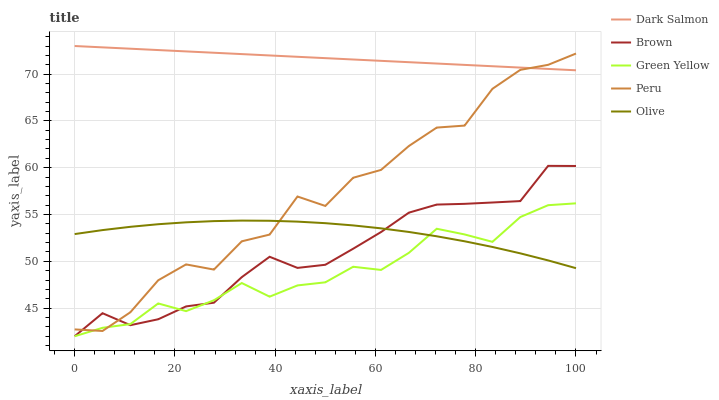Does Green Yellow have the minimum area under the curve?
Answer yes or no. Yes. Does Dark Salmon have the maximum area under the curve?
Answer yes or no. Yes. Does Brown have the minimum area under the curve?
Answer yes or no. No. Does Brown have the maximum area under the curve?
Answer yes or no. No. Is Dark Salmon the smoothest?
Answer yes or no. Yes. Is Peru the roughest?
Answer yes or no. Yes. Is Brown the smoothest?
Answer yes or no. No. Is Brown the roughest?
Answer yes or no. No. Does Brown have the lowest value?
Answer yes or no. Yes. Does Dark Salmon have the lowest value?
Answer yes or no. No. Does Dark Salmon have the highest value?
Answer yes or no. Yes. Does Brown have the highest value?
Answer yes or no. No. Is Green Yellow less than Dark Salmon?
Answer yes or no. Yes. Is Dark Salmon greater than Green Yellow?
Answer yes or no. Yes. Does Olive intersect Green Yellow?
Answer yes or no. Yes. Is Olive less than Green Yellow?
Answer yes or no. No. Is Olive greater than Green Yellow?
Answer yes or no. No. Does Green Yellow intersect Dark Salmon?
Answer yes or no. No. 